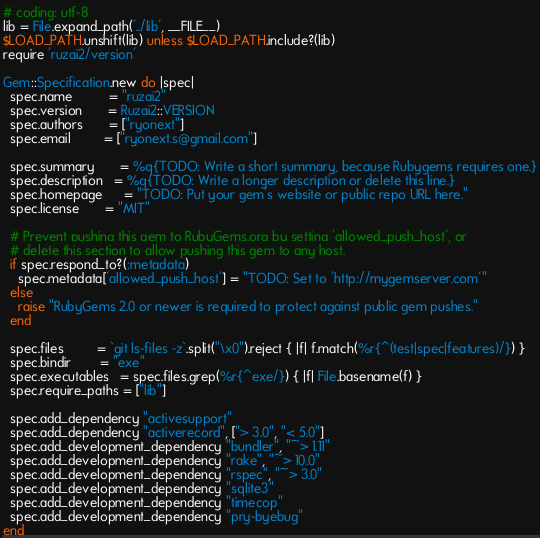Convert code to text. <code><loc_0><loc_0><loc_500><loc_500><_Ruby_># coding: utf-8
lib = File.expand_path('../lib', __FILE__)
$LOAD_PATH.unshift(lib) unless $LOAD_PATH.include?(lib)
require 'ruzai2/version'

Gem::Specification.new do |spec|
  spec.name          = "ruzai2"
  spec.version       = Ruzai2::VERSION
  spec.authors       = ["ryonext"]
  spec.email         = ["ryonext.s@gmail.com"]

  spec.summary       = %q{TODO: Write a short summary, because Rubygems requires one.}
  spec.description   = %q{TODO: Write a longer description or delete this line.}
  spec.homepage      = "TODO: Put your gem's website or public repo URL here."
  spec.license       = "MIT"

  # Prevent pushing this gem to RubyGems.org by setting 'allowed_push_host', or
  # delete this section to allow pushing this gem to any host.
  if spec.respond_to?(:metadata)
    spec.metadata['allowed_push_host'] = "TODO: Set to 'http://mygemserver.com'"
  else
    raise "RubyGems 2.0 or newer is required to protect against public gem pushes."
  end

  spec.files         = `git ls-files -z`.split("\x0").reject { |f| f.match(%r{^(test|spec|features)/}) }
  spec.bindir        = "exe"
  spec.executables   = spec.files.grep(%r{^exe/}) { |f| File.basename(f) }
  spec.require_paths = ["lib"]

  spec.add_dependency "activesupport"
  spec.add_dependency "activerecord", ["> 3.0", "< 5.0"]
  spec.add_development_dependency "bundler", "~> 1.11"
  spec.add_development_dependency "rake", "~> 10.0"
  spec.add_development_dependency "rspec", "~> 3.0"
  spec.add_development_dependency "sqlite3"
  spec.add_development_dependency "timecop"
  spec.add_development_dependency "pry-byebug"
end
</code> 